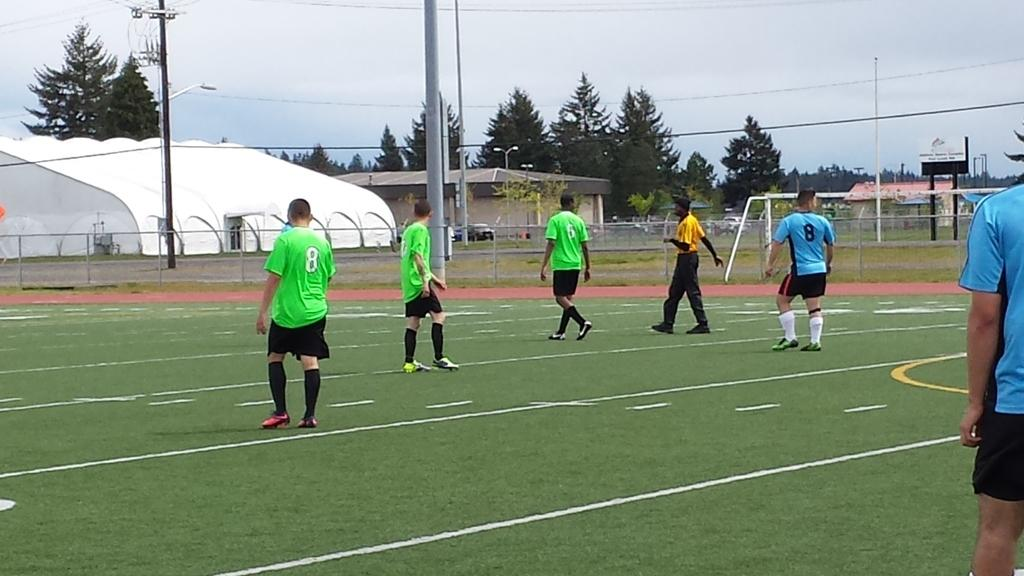Provide a one-sentence caption for the provided image. Soccer player jerseys that have number eight and number six on the back. 